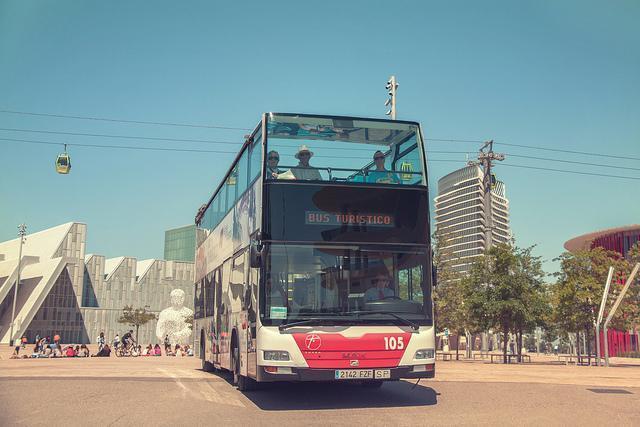How many levels does the bus have?
Give a very brief answer. 2. How many buses are in the picture?
Give a very brief answer. 1. How many buses are there?
Give a very brief answer. 1. 